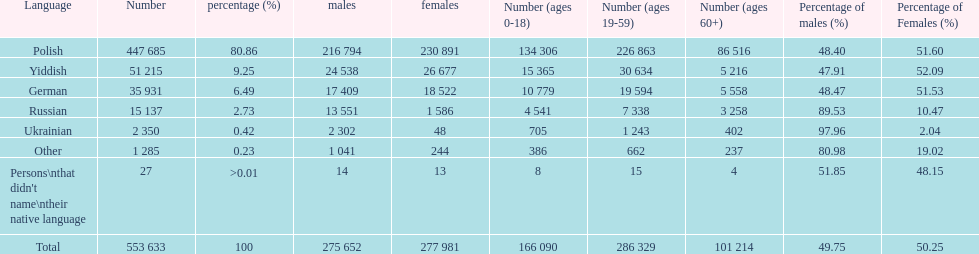Which language did the most people in the imperial census of 1897 speak in the p&#322;ock governorate? Polish. Would you mind parsing the complete table? {'header': ['Language', 'Number', 'percentage (%)', 'males', 'females', 'Number (ages 0-18)', 'Number (ages 19-59)', 'Number (ages 60+)', 'Percentage of males (%)', 'Percentage of Females (%)'], 'rows': [['Polish', '447 685', '80.86', '216 794', '230 891', '134 306', '226 863', '86 516', '48.40', '51.60'], ['Yiddish', '51 215', '9.25', '24 538', '26 677', '15 365', '30 634', '5 216', '47.91', '52.09'], ['German', '35 931', '6.49', '17 409', '18 522', '10 779', '19 594', '5 558', '48.47', '51.53'], ['Russian', '15 137', '2.73', '13 551', '1 586', '4 541', '7 338', '3 258', '89.53', '10.47'], ['Ukrainian', '2 350', '0.42', '2 302', '48', '705', '1 243', '402', '97.96', '2.04'], ['Other', '1 285', '0.23', '1 041', '244', '386', '662', '237', '80.98', '19.02'], ["Persons\\nthat didn't name\\ntheir native language", '27', '>0.01', '14', '13', '8', '15', '4', '51.85', '48.15'], ['Total', '553 633', '100', '275 652', '277 981', '166 090', '286 329', '101 214', '49.75', '50.25']]} 